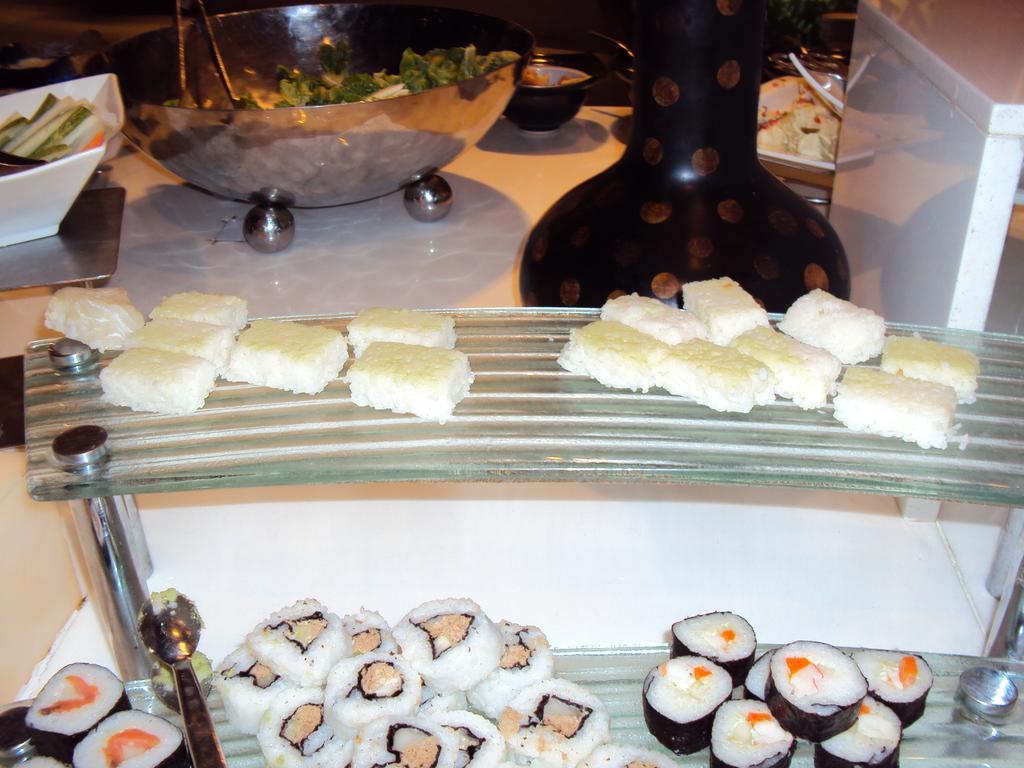How would you summarize this image in a sentence or two? In this image we can see some food places in the racks. We can also see a table containing some food in the bowls and a vase on it. 